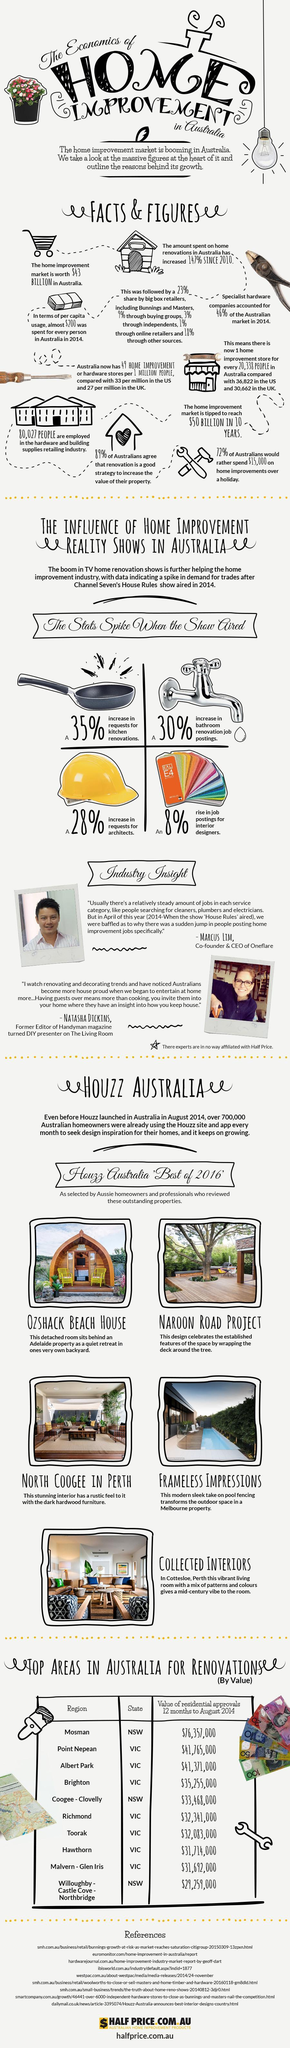How much is the rise in demand for toilet repair work?
Answer the question with a short phrase. 30% What is the second highest residential value in the state of VIC? $41,371,000 Which is the home decoration which has a country feel to it and furnished with dark hardwood? North Coogee in Perth How much is the rise in demand for engineers? 28% What percentage of Australians believe restoration of home enhances the worth of its value? 89% What is the difference between the second and third residential value in the state of NSW? 42,09,000 How many places in NSW are ready for revamping? 3 What percentage of Australians are interested to put more money on home decors than vacations? 72% How much is the increase in no of openings for home decors? 8% Which area in Australia ranks top 3 position in terms of residential worth and revamping? Albert Park 